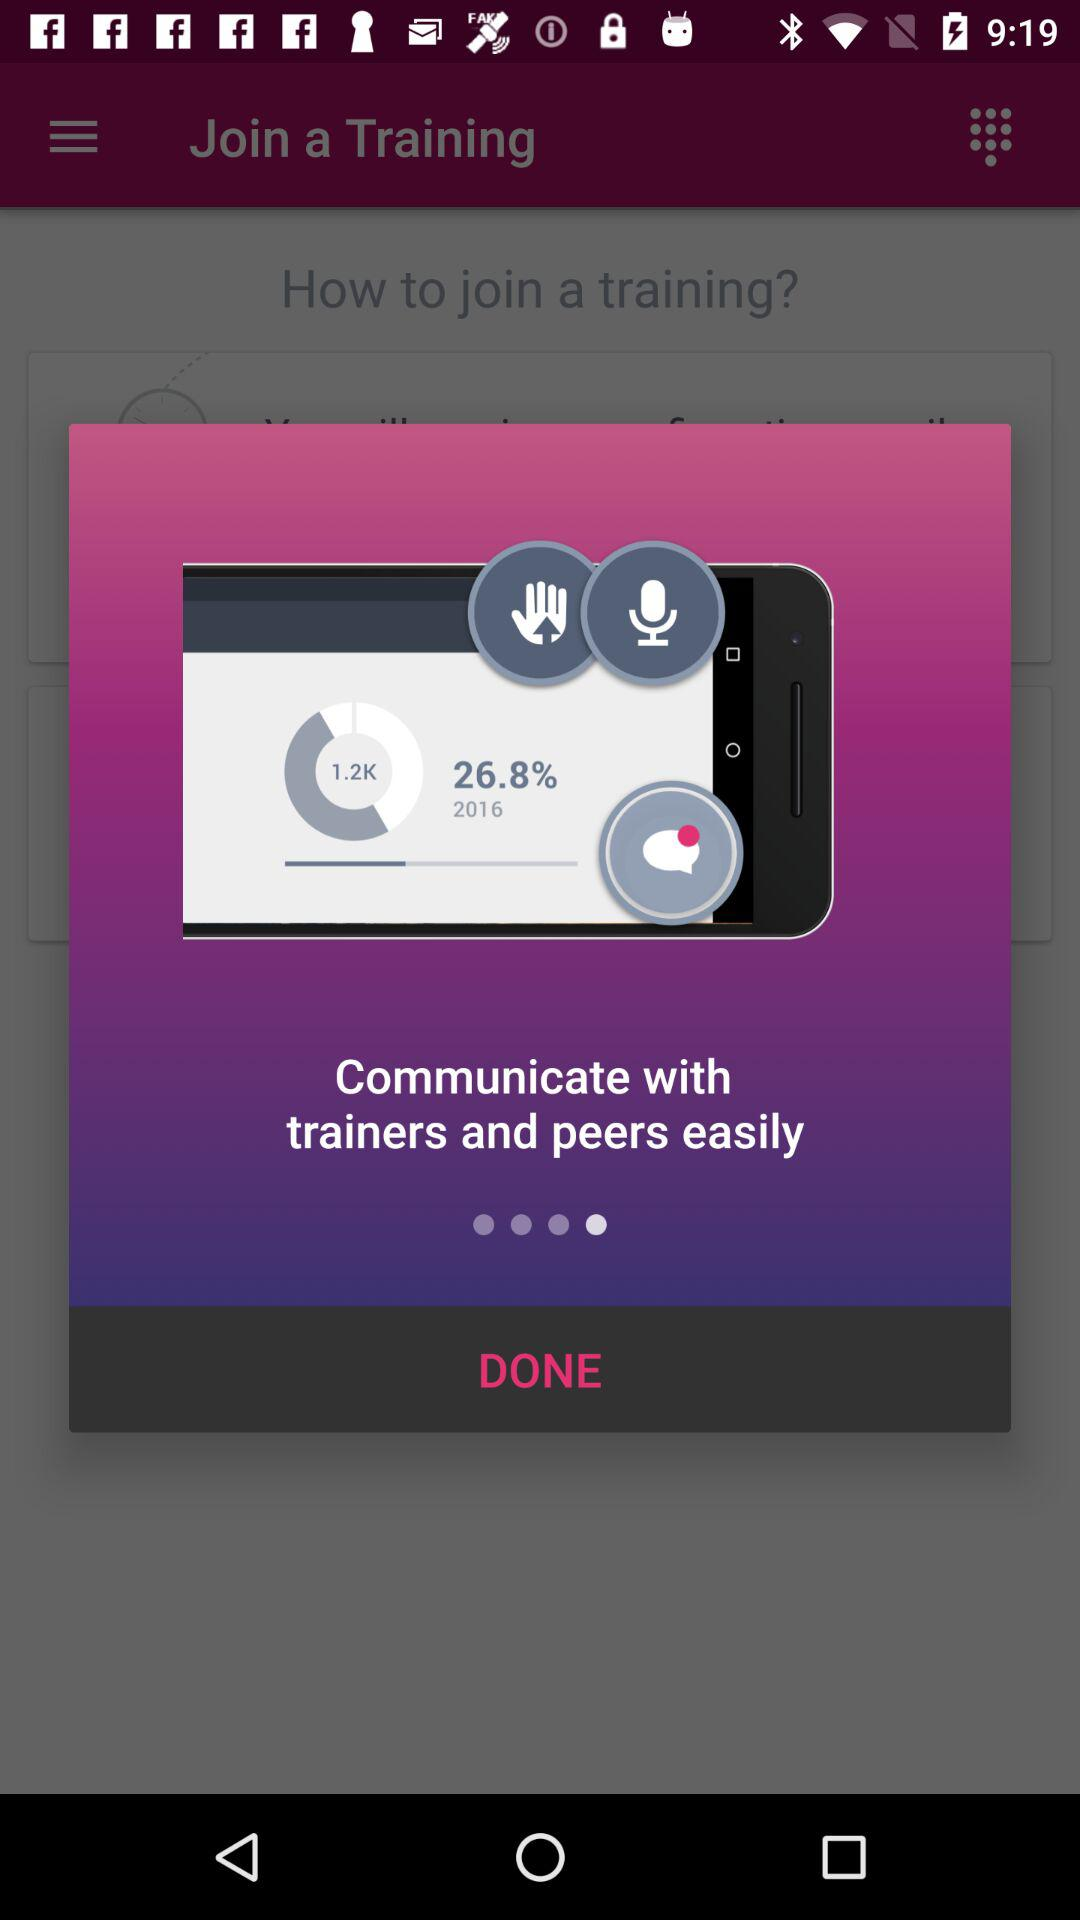Whom can we communicate with? You can communicate with trainers and peers. 